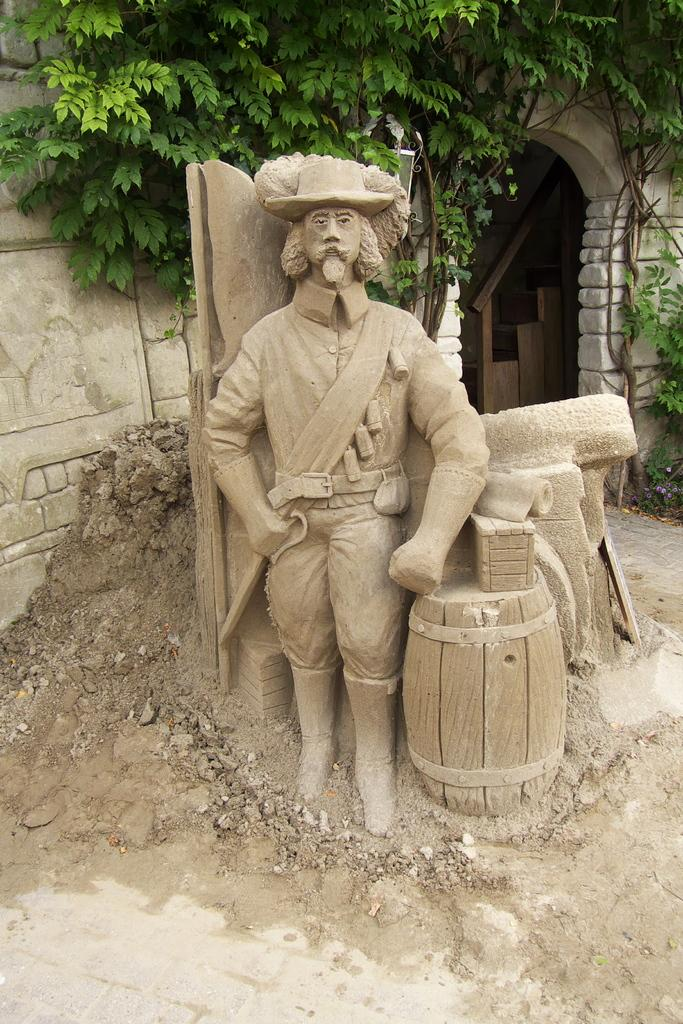What is the main subject of the image? There is a statue of a person in the image. What can be seen near the statue? There are objects to the side of the statue. What is visible in the background of the image? There is a building and trees in the background of the image. Can you tell me how many grapes are on the statue's head in the image? There are no grapes present on the statue's head in the image. What direction is the statue facing in the image? The provided facts do not specify the direction the statue is facing, so it cannot be determined from the image. 